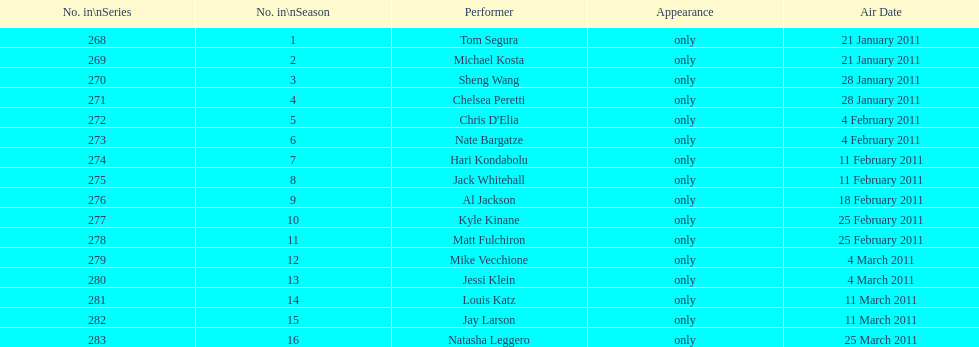In how many episodes was there just one performer? 16. 